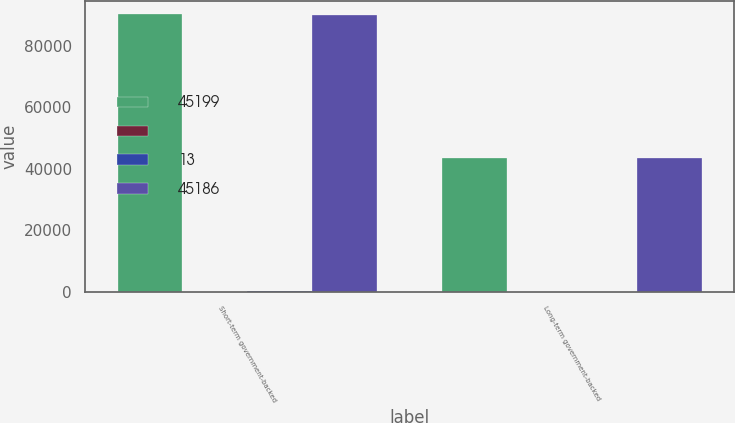Convert chart. <chart><loc_0><loc_0><loc_500><loc_500><stacked_bar_chart><ecel><fcel>Short-term government-backed<fcel>Long-term government-backed<nl><fcel>45199<fcel>90199<fcel>43484<nl><fcel><fcel>1<fcel>5<nl><fcel>13<fcel>87<fcel>18<nl><fcel>45186<fcel>90113<fcel>43471<nl></chart> 